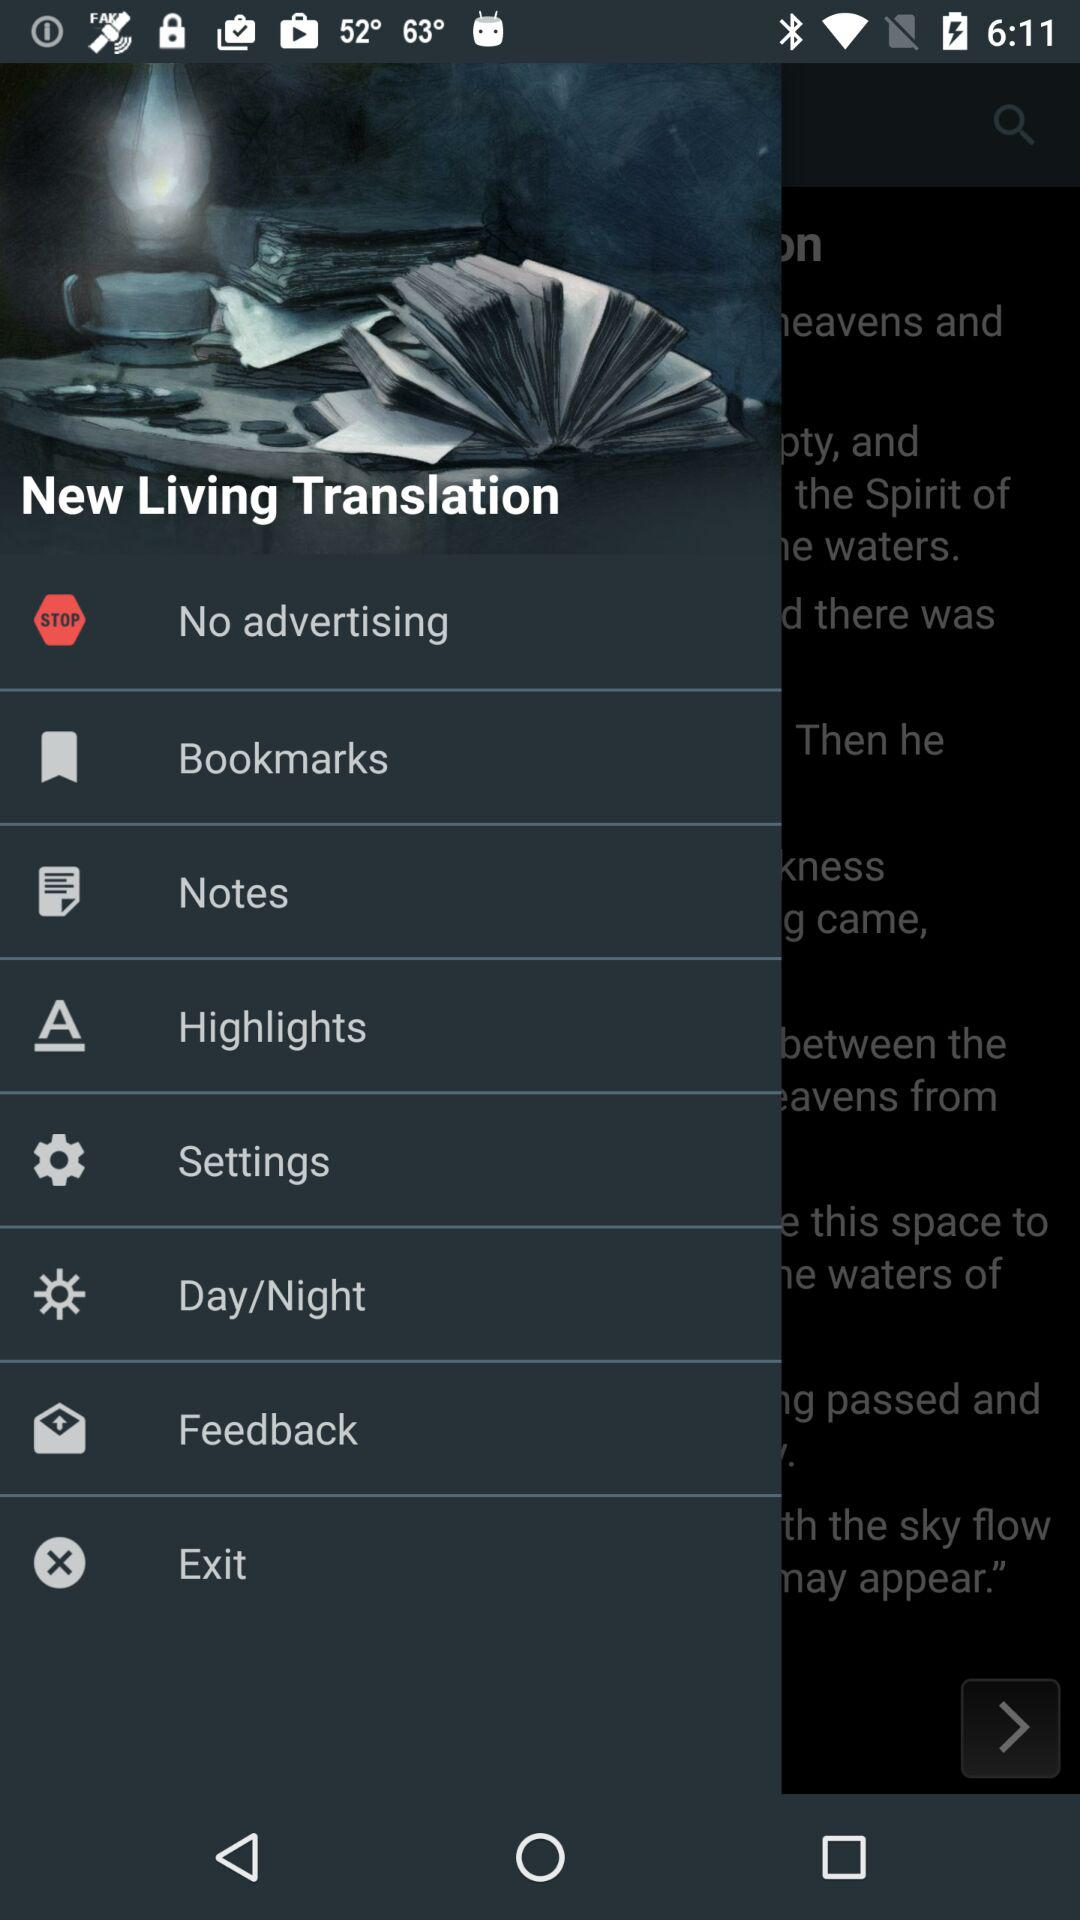What is the name of the application? The name of the application is "New Living Translation". 